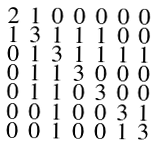<formula> <loc_0><loc_0><loc_500><loc_500>\begin{smallmatrix} 2 & 1 & 0 & 0 & 0 & 0 & 0 \\ 1 & 3 & 1 & 1 & 1 & 0 & 0 \\ 0 & 1 & 3 & 1 & 1 & 1 & 1 \\ 0 & 1 & 1 & 3 & 0 & 0 & 0 \\ 0 & 1 & 1 & 0 & 3 & 0 & 0 \\ 0 & 0 & 1 & 0 & 0 & 3 & 1 \\ 0 & 0 & 1 & 0 & 0 & 1 & 3 \end{smallmatrix}</formula> 